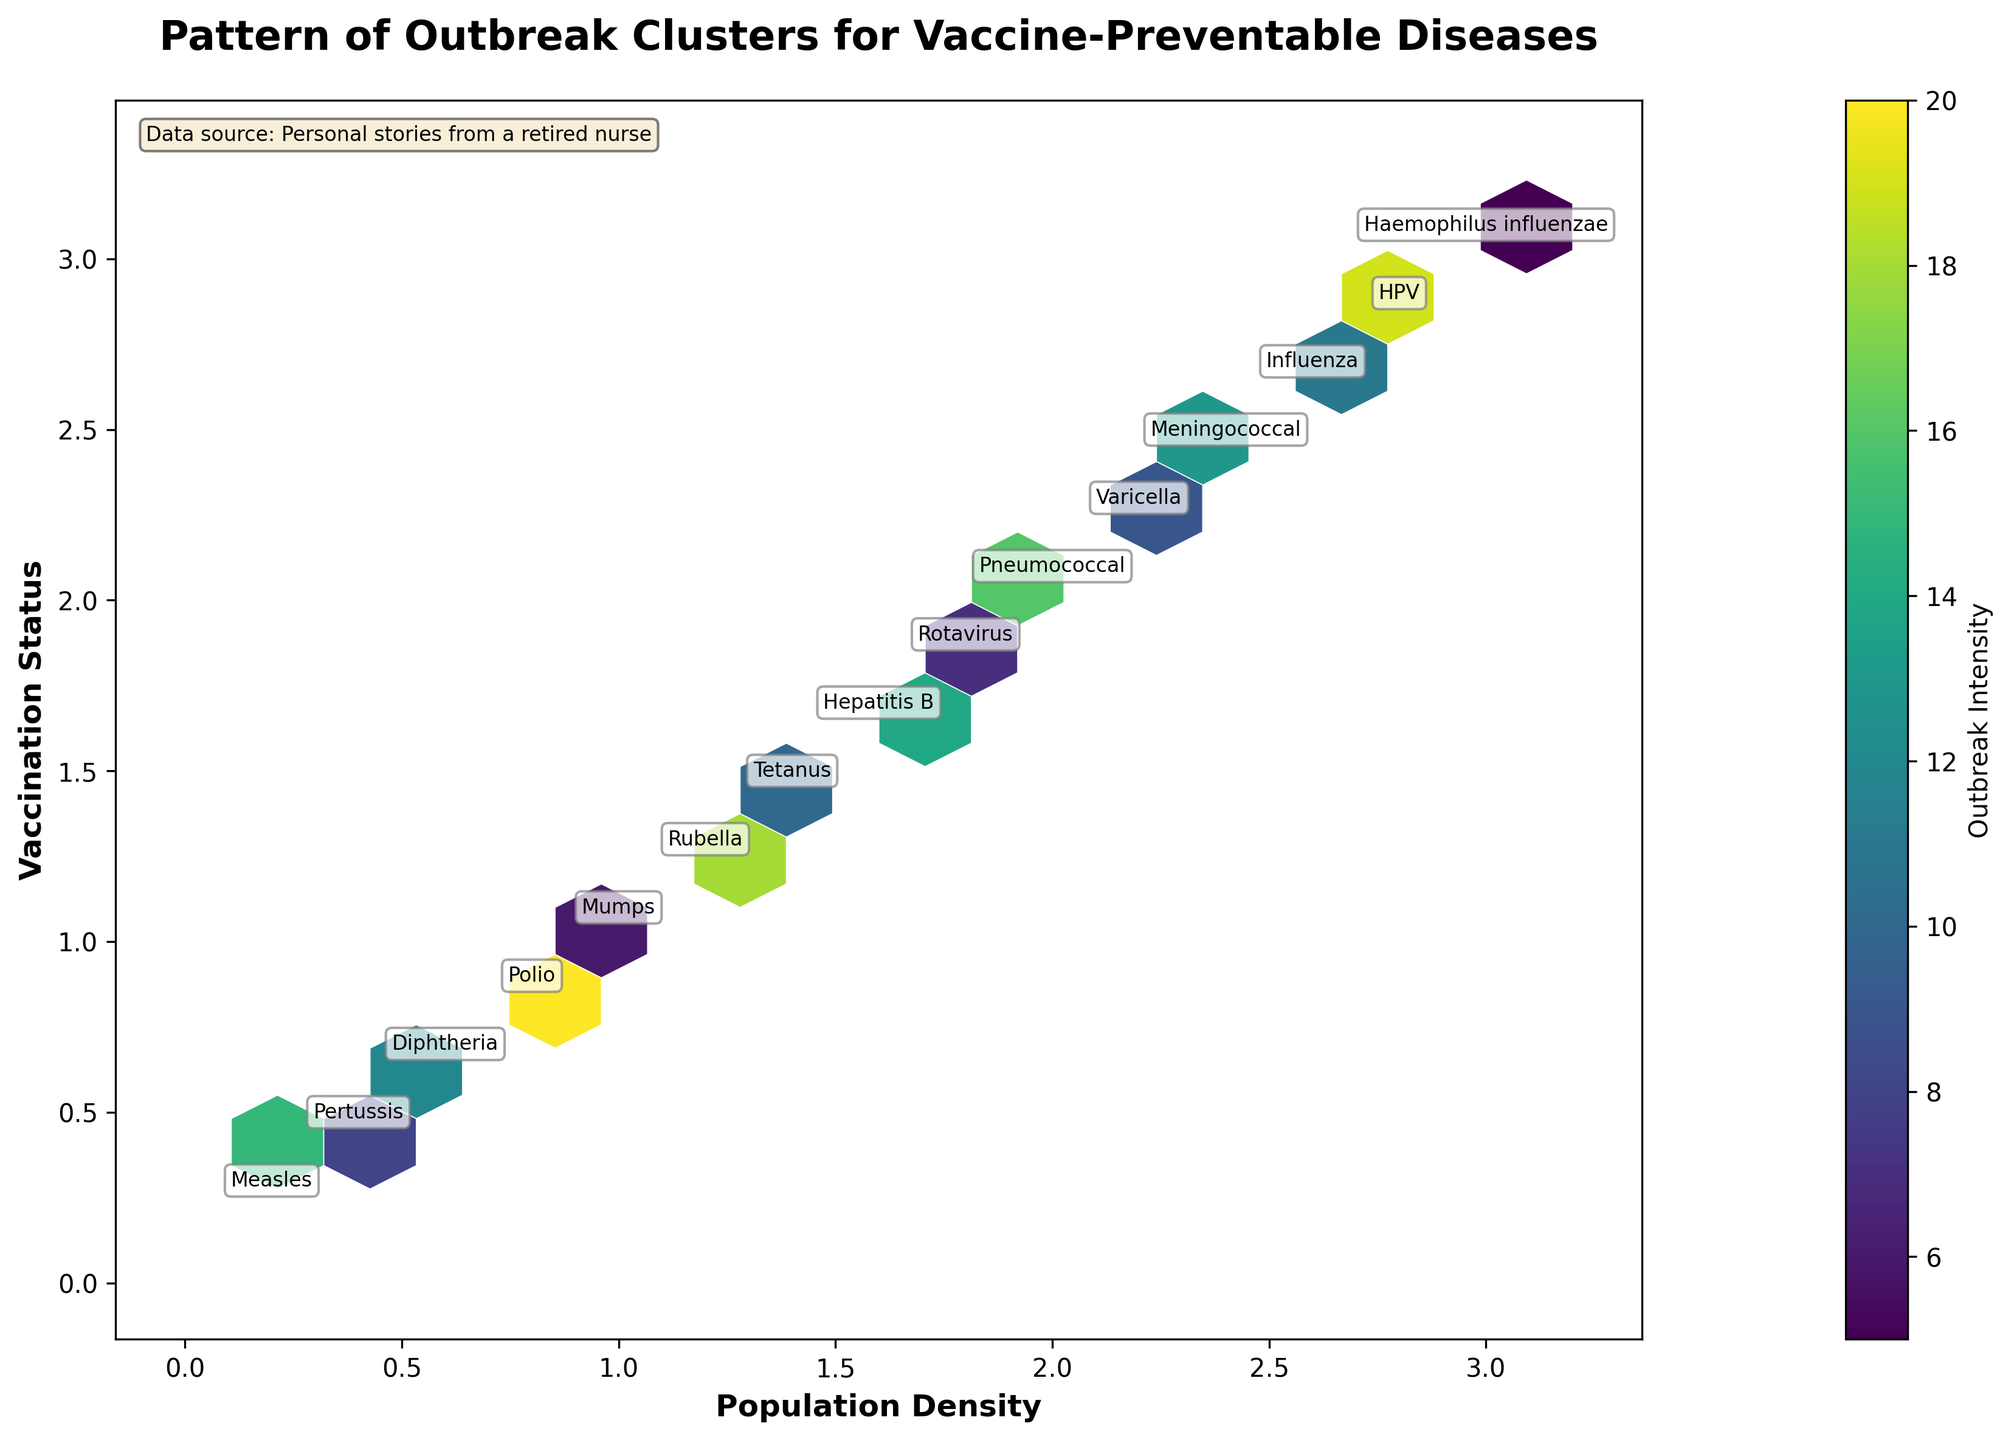What's the title of the figure? The title of the figure is displayed prominently at the top. It reads, "Pattern of Outbreak Clusters for Vaccine-Preventable Diseases."
Answer: Pattern of Outbreak Clusters for Vaccine-Preventable Diseases How many different diseases are annotated in the figure? There are annotations beside each hexagon in the plot indicating different diseases. By counting these annotations, we find there are 15 different diseases.
Answer: 15 Which disease has the highest outbreak intensity, and what is its value? By examining the color intensity and annotations, the disease labeled "Polio" appears in the darkest colored hexagon indicating the highest outbreak intensity. The color bar shows that the highest intensity is 20.
Answer: Polio, 20 What is the vaccination status for Rubella in the figure? The plot shows vaccination status along the y-axis. The annotation for "Rubella" is located around the 1.3 mark.
Answer: Approximately 1.3 Compare the outbreak intensities of Influenza and Meningococcal. Which is higher? By looking at the annotations and the color of the hexagons, Influenza has an outbreak intensity of 11 and Meningococcal has an intensity of 13, according to their respective annotations and hexagon colors.
Answer: Meningococcal Is there any correlation between population density and vaccination status based on the plot? By examining the distribution of hexagons, many points appear diagonally across the plot, suggesting a potential positive correlation between population density and vaccination status. However, for definitive correlation, further statistical analysis is needed.
Answer: Potential positive correlation Which location has an outbreak of both Measles and Rotavirus? By referring to the annotations, "New York City" has an outbreak of Measles, and "Dallas" has an outbreak of Rotavirus. None of these locations overlap for these diseases.
Answer: None What is the outbreak intensity for Mumps? The annotation for "Mumps" is located around a hexagon with moderate intensity, which corresponds to the value of 6 according to the color bar.
Answer: 6 Determine the average outbreak intensity of Diphtheria and Hepatitis B. The outbreak intensity for Diphtheria is 12, and for Hepatitis B, it is 14. The average of these two values is (12 + 14) / 2 = 13.
Answer: 13 